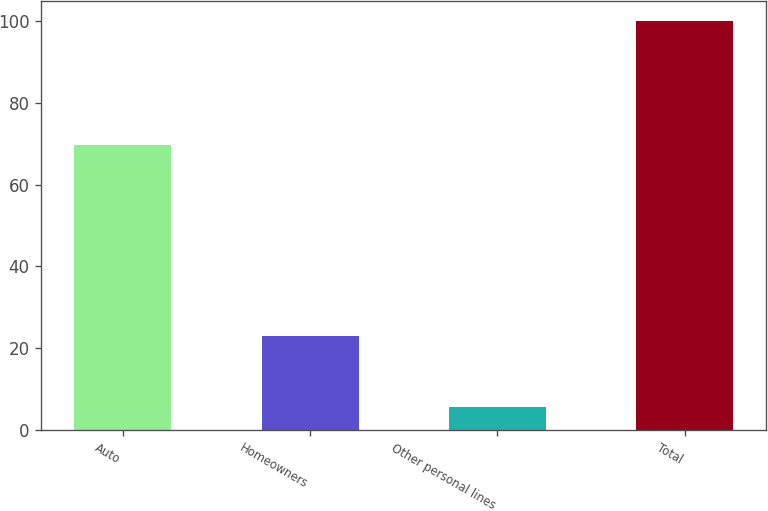Convert chart to OTSL. <chart><loc_0><loc_0><loc_500><loc_500><bar_chart><fcel>Auto<fcel>Homeowners<fcel>Other personal lines<fcel>Total<nl><fcel>69.6<fcel>22.9<fcel>5.5<fcel>100<nl></chart> 